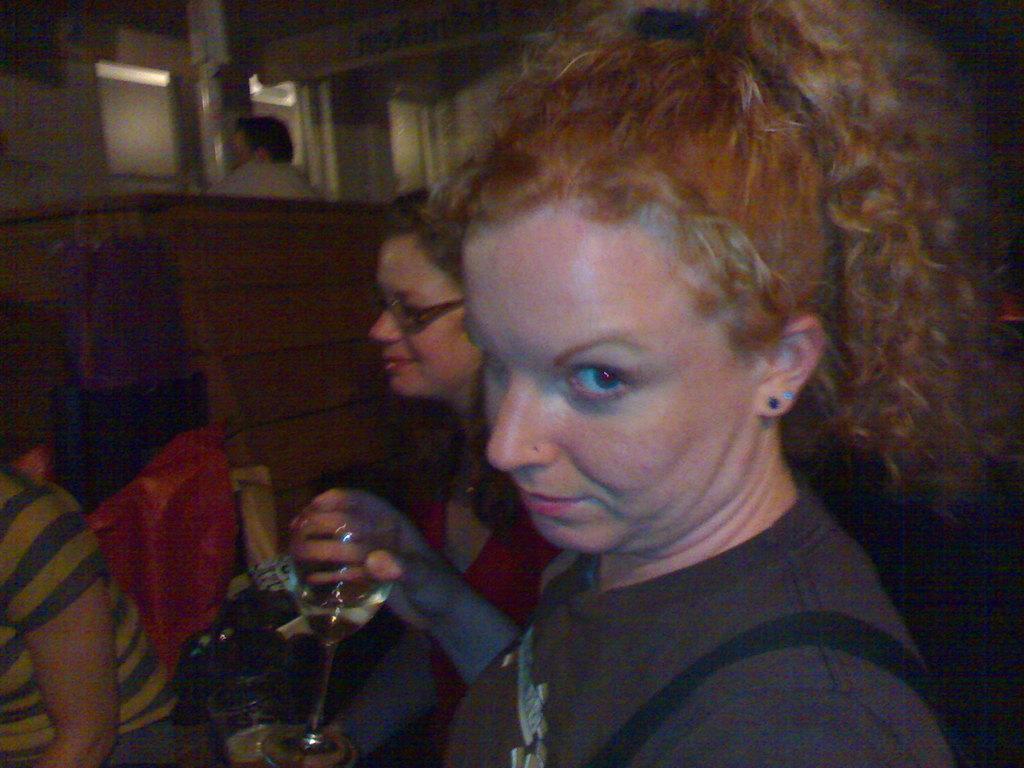Could you give a brief overview of what you see in this image? In this image I can see people among them this woman is holding a glass in the hand. In the background I can see some objects. 